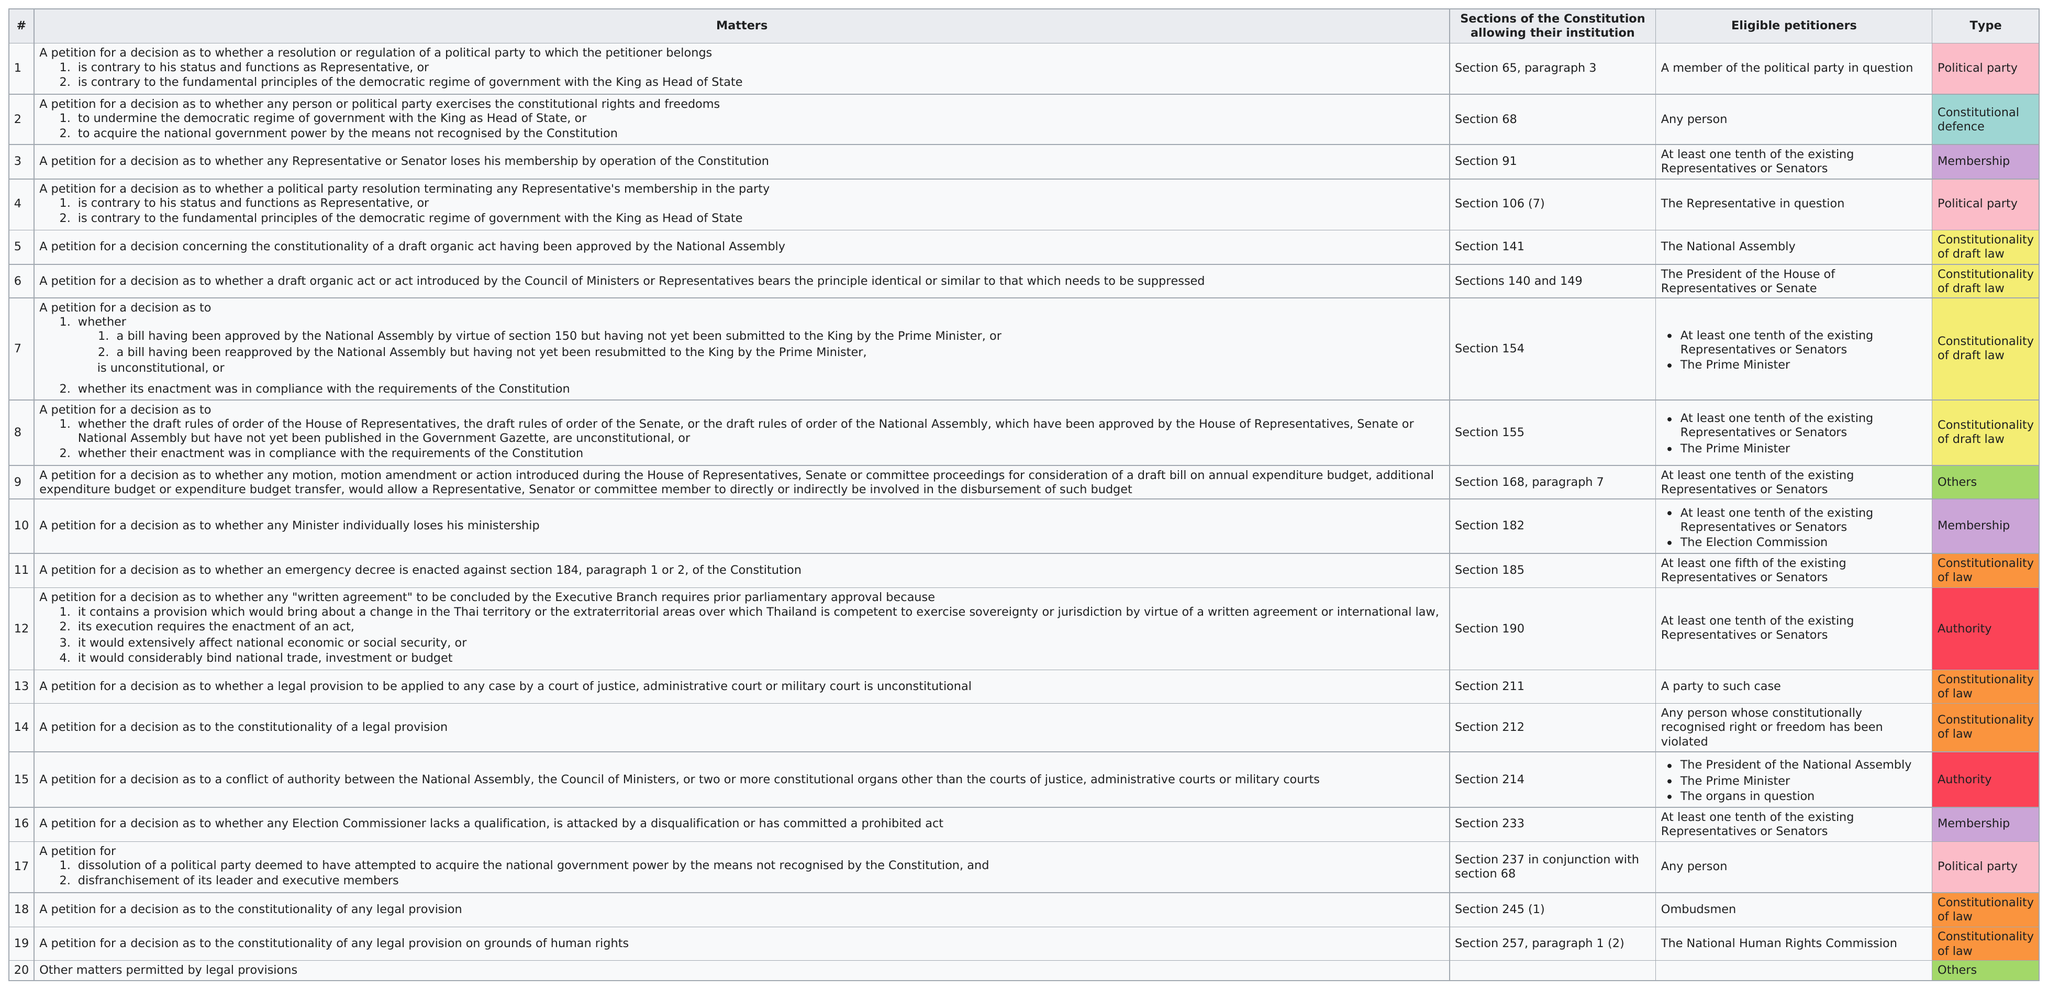Mention a couple of crucial points in this snapshot. It is true that any person can petition matters 2 and 17. Out of the total number of matters that have been assigned a type, three of them have been identified as having a political party as their type. Seven matters require at least one tenth of the existing representatives or senators. Any person is eligible to file petitions for matters 2 and 17. 